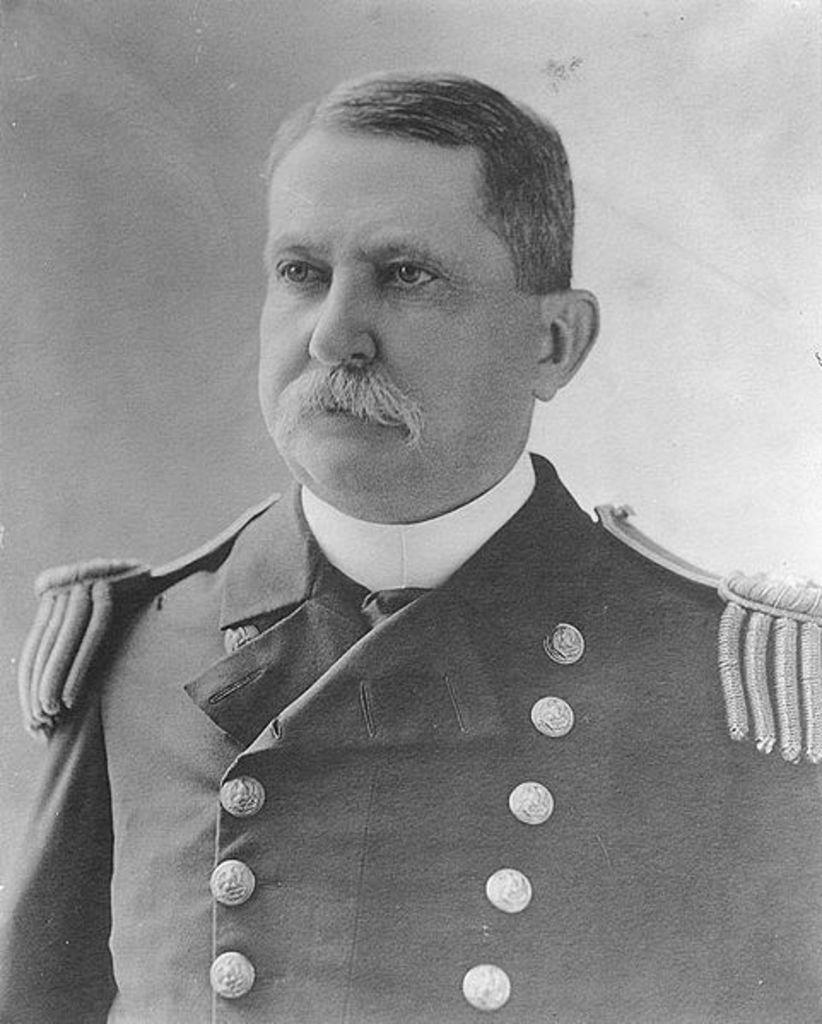What is the color scheme of the image? The image is black and white. Can you describe the main subject of the image? There is a person in the image. What type of pickle is the person holding in the image? There is no pickle present in the image; it is a black and white image with a person as the main subject. 